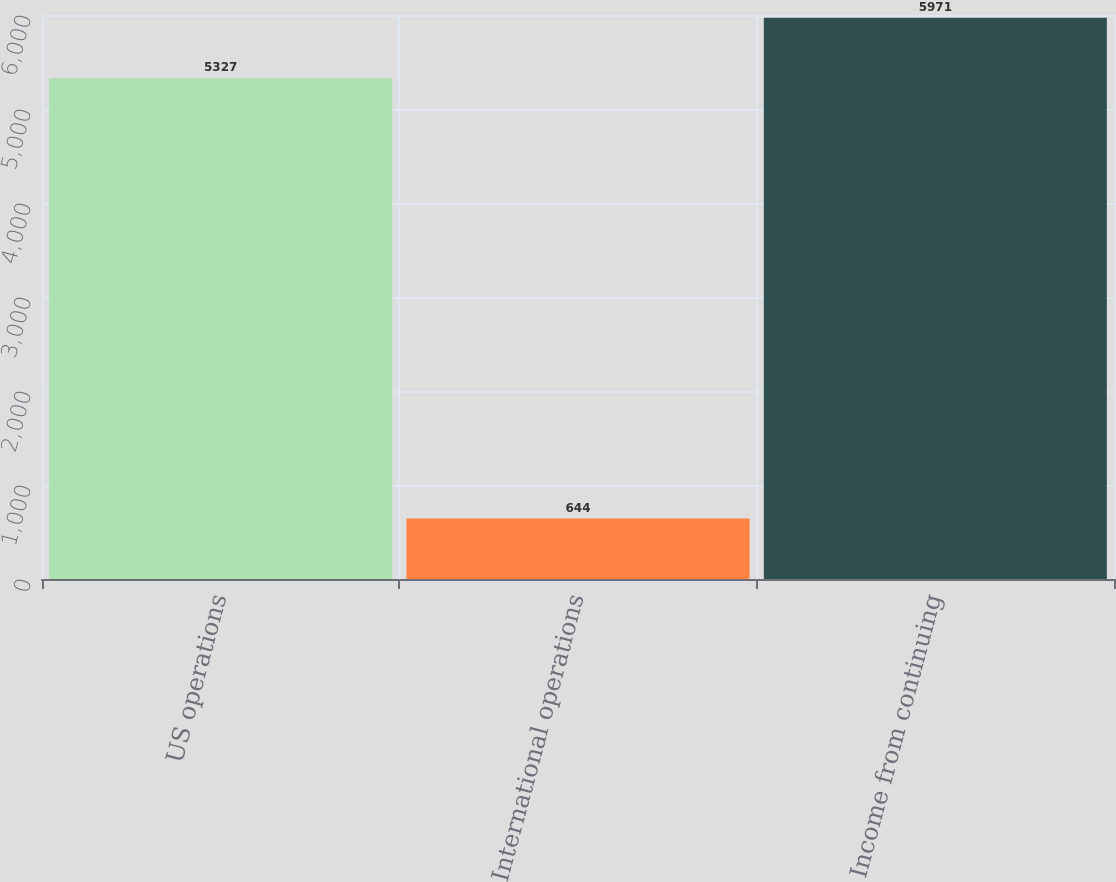Convert chart to OTSL. <chart><loc_0><loc_0><loc_500><loc_500><bar_chart><fcel>US operations<fcel>International operations<fcel>Income from continuing<nl><fcel>5327<fcel>644<fcel>5971<nl></chart> 